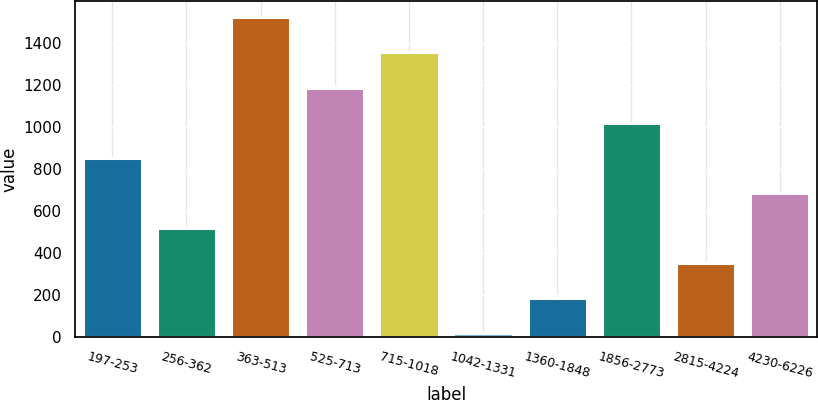Convert chart to OTSL. <chart><loc_0><loc_0><loc_500><loc_500><bar_chart><fcel>197-253<fcel>256-362<fcel>363-513<fcel>525-713<fcel>715-1018<fcel>1042-1331<fcel>1360-1848<fcel>1856-2773<fcel>2815-4224<fcel>4230-6226<nl><fcel>855<fcel>520.6<fcel>1523.8<fcel>1189.4<fcel>1356.6<fcel>19<fcel>186.2<fcel>1022.2<fcel>353.4<fcel>687.8<nl></chart> 